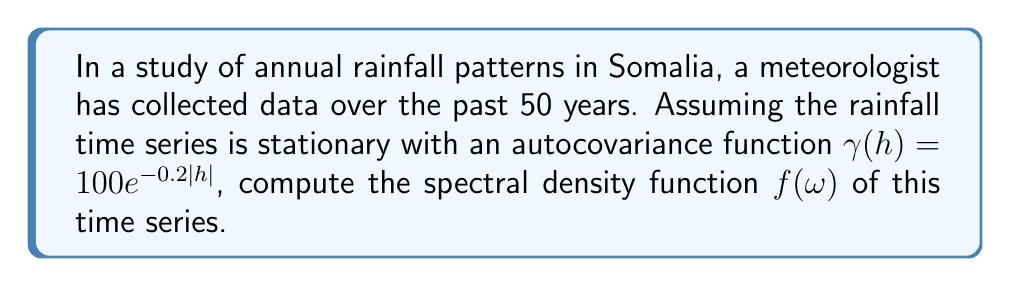Can you answer this question? To compute the spectral density function of a stationary time series, we follow these steps:

1) The spectral density function $f(\omega)$ is defined as the Fourier transform of the autocovariance function $\gamma(h)$:

   $$f(\omega) = \frac{1}{2\pi} \sum_{h=-\infty}^{\infty} \gamma(h) e^{-i\omega h}$$

2) Given the autocovariance function $\gamma(h) = 100e^{-0.2|h|}$, we can simplify our calculation by using the fact that the Fourier transform of an exponential function is a Lorentzian function.

3) For a general exponential autocovariance function $\gamma(h) = \sigma^2 e^{-\alpha|h|}$, the spectral density function is:

   $$f(\omega) = \frac{\sigma^2 \alpha}{\pi(\alpha^2 + \omega^2)}$$

4) In our case, $\sigma^2 = 100$ and $\alpha = 0.2$. Substituting these values:

   $$f(\omega) = \frac{100 \cdot 0.2}{\pi(0.2^2 + \omega^2)}$$

5) Simplifying:

   $$f(\omega) = \frac{20}{\pi(0.04 + \omega^2)}$$

This is the spectral density function for the given stationary time series.
Answer: $$f(\omega) = \frac{20}{\pi(0.04 + \omega^2)}$$ 